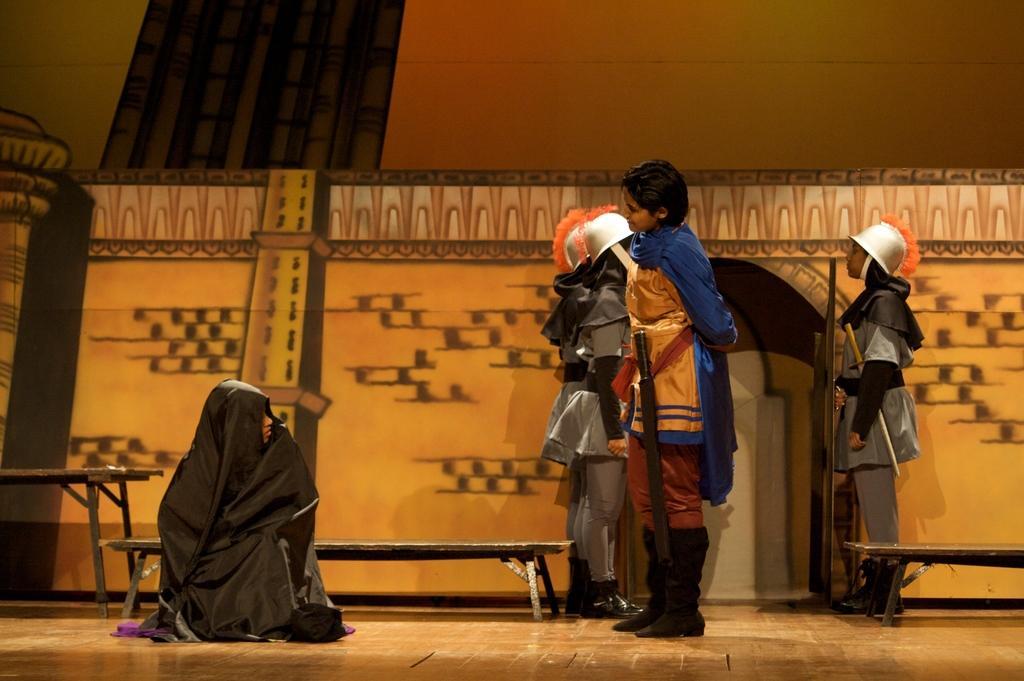Could you give a brief overview of what you see in this image? In this image there is a person in the middle who is wearing the costume of a warrior. On the left side bottom there is a person sitting on the floor by covering with the black color cloth. In the background it seems like there are two soldiers. Behind them there is a wall. There are benches on the floor. 